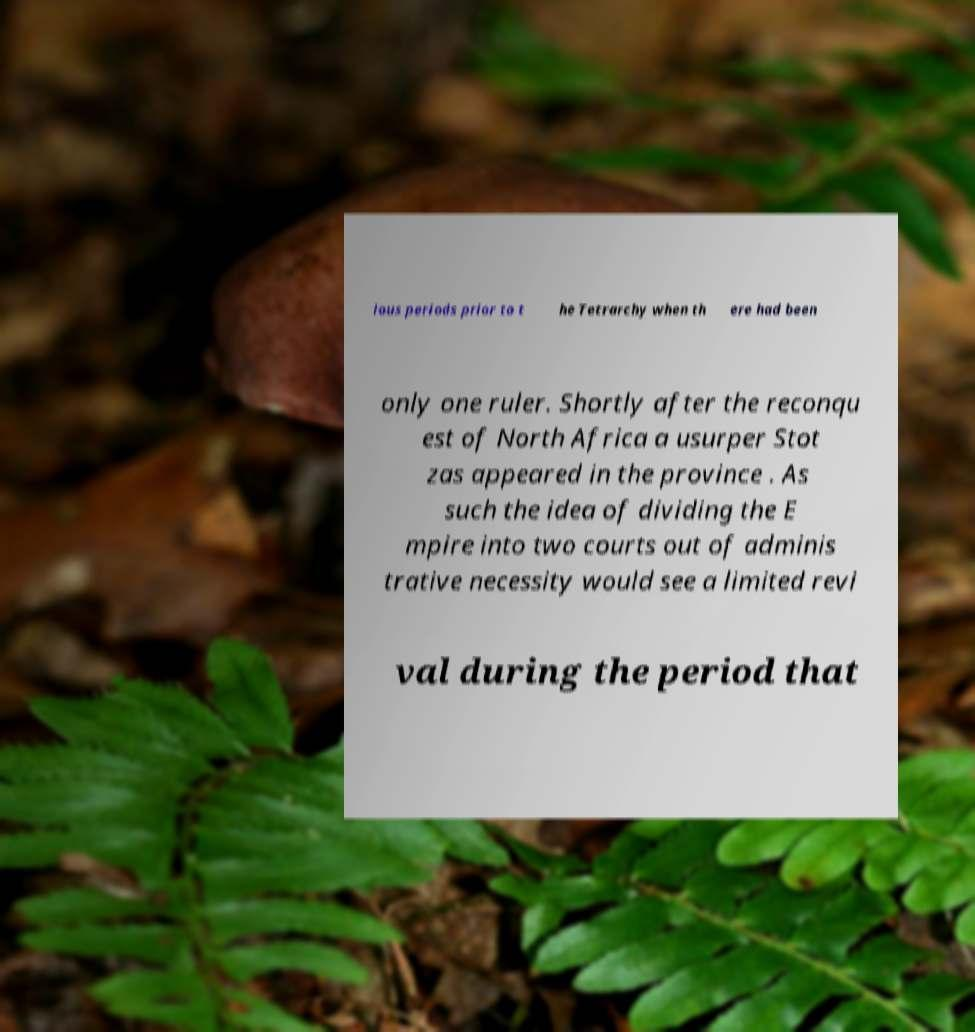Can you accurately transcribe the text from the provided image for me? ious periods prior to t he Tetrarchy when th ere had been only one ruler. Shortly after the reconqu est of North Africa a usurper Stot zas appeared in the province . As such the idea of dividing the E mpire into two courts out of adminis trative necessity would see a limited revi val during the period that 